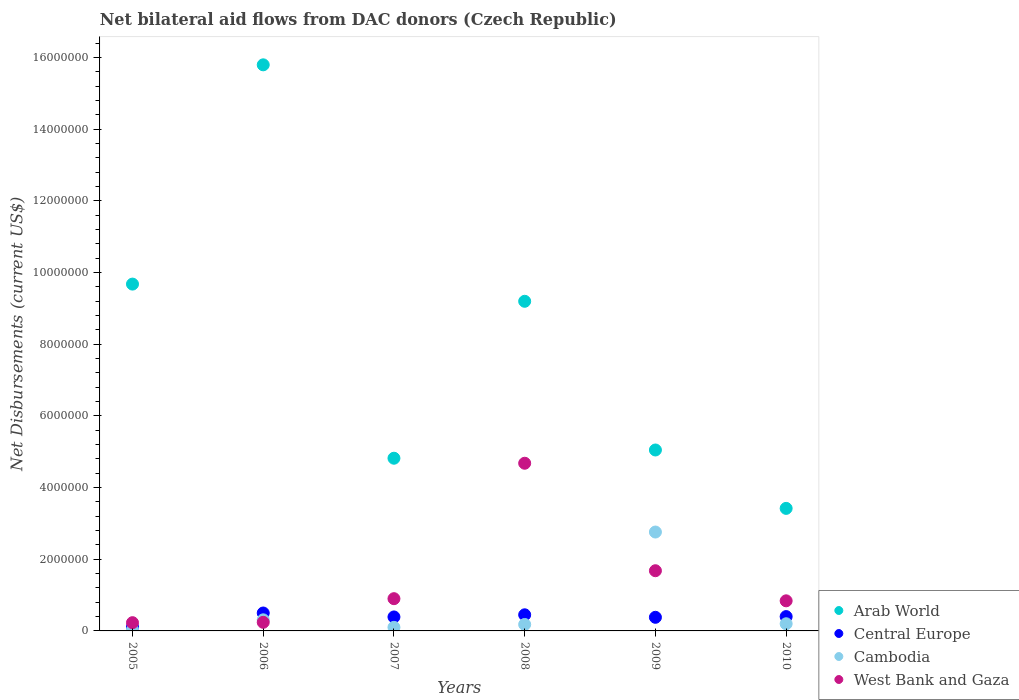How many different coloured dotlines are there?
Ensure brevity in your answer.  4. What is the net bilateral aid flows in West Bank and Gaza in 2010?
Ensure brevity in your answer.  8.40e+05. Across all years, what is the maximum net bilateral aid flows in Central Europe?
Your response must be concise. 5.00e+05. Across all years, what is the minimum net bilateral aid flows in Cambodia?
Your answer should be very brief. 3.00e+04. In which year was the net bilateral aid flows in Arab World maximum?
Your response must be concise. 2006. What is the total net bilateral aid flows in Central Europe in the graph?
Offer a very short reply. 2.23e+06. What is the difference between the net bilateral aid flows in Central Europe in 2006 and the net bilateral aid flows in Cambodia in 2010?
Make the answer very short. 3.00e+05. What is the average net bilateral aid flows in Cambodia per year?
Your response must be concise. 5.97e+05. In the year 2006, what is the difference between the net bilateral aid flows in Arab World and net bilateral aid flows in West Bank and Gaza?
Give a very brief answer. 1.56e+07. In how many years, is the net bilateral aid flows in Arab World greater than 9600000 US$?
Give a very brief answer. 2. What is the ratio of the net bilateral aid flows in Cambodia in 2006 to that in 2007?
Ensure brevity in your answer.  3.1. Is the difference between the net bilateral aid flows in Arab World in 2007 and 2008 greater than the difference between the net bilateral aid flows in West Bank and Gaza in 2007 and 2008?
Make the answer very short. No. What is the difference between the highest and the second highest net bilateral aid flows in Arab World?
Offer a terse response. 6.12e+06. What is the difference between the highest and the lowest net bilateral aid flows in Arab World?
Give a very brief answer. 1.24e+07. Does the net bilateral aid flows in Arab World monotonically increase over the years?
Provide a succinct answer. No. Is the net bilateral aid flows in West Bank and Gaza strictly greater than the net bilateral aid flows in Cambodia over the years?
Provide a short and direct response. No. Is the net bilateral aid flows in Central Europe strictly less than the net bilateral aid flows in Cambodia over the years?
Your answer should be very brief. No. Are the values on the major ticks of Y-axis written in scientific E-notation?
Make the answer very short. No. Does the graph contain any zero values?
Your response must be concise. No. How many legend labels are there?
Your answer should be very brief. 4. How are the legend labels stacked?
Your response must be concise. Vertical. What is the title of the graph?
Your response must be concise. Net bilateral aid flows from DAC donors (Czech Republic). Does "Turks and Caicos Islands" appear as one of the legend labels in the graph?
Your answer should be compact. No. What is the label or title of the X-axis?
Your response must be concise. Years. What is the label or title of the Y-axis?
Offer a terse response. Net Disbursements (current US$). What is the Net Disbursements (current US$) of Arab World in 2005?
Make the answer very short. 9.68e+06. What is the Net Disbursements (current US$) in West Bank and Gaza in 2005?
Keep it short and to the point. 2.30e+05. What is the Net Disbursements (current US$) in Arab World in 2006?
Give a very brief answer. 1.58e+07. What is the Net Disbursements (current US$) in Central Europe in 2006?
Your answer should be very brief. 5.00e+05. What is the Net Disbursements (current US$) of Arab World in 2007?
Your response must be concise. 4.82e+06. What is the Net Disbursements (current US$) of Central Europe in 2007?
Offer a terse response. 3.90e+05. What is the Net Disbursements (current US$) of Cambodia in 2007?
Your answer should be very brief. 1.00e+05. What is the Net Disbursements (current US$) in Arab World in 2008?
Offer a terse response. 9.20e+06. What is the Net Disbursements (current US$) in Central Europe in 2008?
Provide a succinct answer. 4.50e+05. What is the Net Disbursements (current US$) of West Bank and Gaza in 2008?
Offer a very short reply. 4.68e+06. What is the Net Disbursements (current US$) in Arab World in 2009?
Offer a terse response. 5.05e+06. What is the Net Disbursements (current US$) in Cambodia in 2009?
Make the answer very short. 2.76e+06. What is the Net Disbursements (current US$) in West Bank and Gaza in 2009?
Offer a very short reply. 1.68e+06. What is the Net Disbursements (current US$) of Arab World in 2010?
Make the answer very short. 3.42e+06. What is the Net Disbursements (current US$) of Cambodia in 2010?
Your answer should be very brief. 2.00e+05. What is the Net Disbursements (current US$) of West Bank and Gaza in 2010?
Your answer should be very brief. 8.40e+05. Across all years, what is the maximum Net Disbursements (current US$) in Arab World?
Your response must be concise. 1.58e+07. Across all years, what is the maximum Net Disbursements (current US$) of Cambodia?
Provide a short and direct response. 2.76e+06. Across all years, what is the maximum Net Disbursements (current US$) of West Bank and Gaza?
Your answer should be compact. 4.68e+06. Across all years, what is the minimum Net Disbursements (current US$) of Arab World?
Offer a very short reply. 3.42e+06. Across all years, what is the minimum Net Disbursements (current US$) in Central Europe?
Offer a very short reply. 1.10e+05. What is the total Net Disbursements (current US$) of Arab World in the graph?
Make the answer very short. 4.80e+07. What is the total Net Disbursements (current US$) of Central Europe in the graph?
Provide a succinct answer. 2.23e+06. What is the total Net Disbursements (current US$) of Cambodia in the graph?
Your answer should be very brief. 3.58e+06. What is the total Net Disbursements (current US$) in West Bank and Gaza in the graph?
Offer a terse response. 8.57e+06. What is the difference between the Net Disbursements (current US$) in Arab World in 2005 and that in 2006?
Offer a terse response. -6.12e+06. What is the difference between the Net Disbursements (current US$) of Central Europe in 2005 and that in 2006?
Your answer should be very brief. -3.90e+05. What is the difference between the Net Disbursements (current US$) of Cambodia in 2005 and that in 2006?
Give a very brief answer. -2.80e+05. What is the difference between the Net Disbursements (current US$) in Arab World in 2005 and that in 2007?
Give a very brief answer. 4.86e+06. What is the difference between the Net Disbursements (current US$) in Central Europe in 2005 and that in 2007?
Make the answer very short. -2.80e+05. What is the difference between the Net Disbursements (current US$) in Cambodia in 2005 and that in 2007?
Offer a terse response. -7.00e+04. What is the difference between the Net Disbursements (current US$) of West Bank and Gaza in 2005 and that in 2007?
Your response must be concise. -6.70e+05. What is the difference between the Net Disbursements (current US$) in Central Europe in 2005 and that in 2008?
Your answer should be compact. -3.40e+05. What is the difference between the Net Disbursements (current US$) of West Bank and Gaza in 2005 and that in 2008?
Offer a very short reply. -4.45e+06. What is the difference between the Net Disbursements (current US$) in Arab World in 2005 and that in 2009?
Offer a terse response. 4.63e+06. What is the difference between the Net Disbursements (current US$) in Central Europe in 2005 and that in 2009?
Offer a terse response. -2.70e+05. What is the difference between the Net Disbursements (current US$) in Cambodia in 2005 and that in 2009?
Your answer should be compact. -2.73e+06. What is the difference between the Net Disbursements (current US$) in West Bank and Gaza in 2005 and that in 2009?
Your answer should be compact. -1.45e+06. What is the difference between the Net Disbursements (current US$) of Arab World in 2005 and that in 2010?
Give a very brief answer. 6.26e+06. What is the difference between the Net Disbursements (current US$) in Central Europe in 2005 and that in 2010?
Your response must be concise. -2.90e+05. What is the difference between the Net Disbursements (current US$) in Cambodia in 2005 and that in 2010?
Ensure brevity in your answer.  -1.70e+05. What is the difference between the Net Disbursements (current US$) in West Bank and Gaza in 2005 and that in 2010?
Your answer should be compact. -6.10e+05. What is the difference between the Net Disbursements (current US$) in Arab World in 2006 and that in 2007?
Provide a short and direct response. 1.10e+07. What is the difference between the Net Disbursements (current US$) of Central Europe in 2006 and that in 2007?
Your answer should be very brief. 1.10e+05. What is the difference between the Net Disbursements (current US$) of Cambodia in 2006 and that in 2007?
Ensure brevity in your answer.  2.10e+05. What is the difference between the Net Disbursements (current US$) in West Bank and Gaza in 2006 and that in 2007?
Keep it short and to the point. -6.60e+05. What is the difference between the Net Disbursements (current US$) in Arab World in 2006 and that in 2008?
Your response must be concise. 6.60e+06. What is the difference between the Net Disbursements (current US$) in Central Europe in 2006 and that in 2008?
Keep it short and to the point. 5.00e+04. What is the difference between the Net Disbursements (current US$) of Cambodia in 2006 and that in 2008?
Make the answer very short. 1.30e+05. What is the difference between the Net Disbursements (current US$) of West Bank and Gaza in 2006 and that in 2008?
Give a very brief answer. -4.44e+06. What is the difference between the Net Disbursements (current US$) of Arab World in 2006 and that in 2009?
Keep it short and to the point. 1.08e+07. What is the difference between the Net Disbursements (current US$) of Cambodia in 2006 and that in 2009?
Provide a succinct answer. -2.45e+06. What is the difference between the Net Disbursements (current US$) of West Bank and Gaza in 2006 and that in 2009?
Give a very brief answer. -1.44e+06. What is the difference between the Net Disbursements (current US$) in Arab World in 2006 and that in 2010?
Your answer should be very brief. 1.24e+07. What is the difference between the Net Disbursements (current US$) in Central Europe in 2006 and that in 2010?
Keep it short and to the point. 1.00e+05. What is the difference between the Net Disbursements (current US$) of West Bank and Gaza in 2006 and that in 2010?
Provide a succinct answer. -6.00e+05. What is the difference between the Net Disbursements (current US$) in Arab World in 2007 and that in 2008?
Provide a succinct answer. -4.38e+06. What is the difference between the Net Disbursements (current US$) in Central Europe in 2007 and that in 2008?
Provide a short and direct response. -6.00e+04. What is the difference between the Net Disbursements (current US$) of Cambodia in 2007 and that in 2008?
Offer a very short reply. -8.00e+04. What is the difference between the Net Disbursements (current US$) of West Bank and Gaza in 2007 and that in 2008?
Make the answer very short. -3.78e+06. What is the difference between the Net Disbursements (current US$) in Cambodia in 2007 and that in 2009?
Your answer should be compact. -2.66e+06. What is the difference between the Net Disbursements (current US$) of West Bank and Gaza in 2007 and that in 2009?
Offer a terse response. -7.80e+05. What is the difference between the Net Disbursements (current US$) in Arab World in 2007 and that in 2010?
Ensure brevity in your answer.  1.40e+06. What is the difference between the Net Disbursements (current US$) in Central Europe in 2007 and that in 2010?
Keep it short and to the point. -10000. What is the difference between the Net Disbursements (current US$) in Arab World in 2008 and that in 2009?
Your response must be concise. 4.15e+06. What is the difference between the Net Disbursements (current US$) of Cambodia in 2008 and that in 2009?
Offer a terse response. -2.58e+06. What is the difference between the Net Disbursements (current US$) of Arab World in 2008 and that in 2010?
Make the answer very short. 5.78e+06. What is the difference between the Net Disbursements (current US$) in Central Europe in 2008 and that in 2010?
Offer a very short reply. 5.00e+04. What is the difference between the Net Disbursements (current US$) in West Bank and Gaza in 2008 and that in 2010?
Give a very brief answer. 3.84e+06. What is the difference between the Net Disbursements (current US$) in Arab World in 2009 and that in 2010?
Offer a terse response. 1.63e+06. What is the difference between the Net Disbursements (current US$) in Cambodia in 2009 and that in 2010?
Your response must be concise. 2.56e+06. What is the difference between the Net Disbursements (current US$) of West Bank and Gaza in 2009 and that in 2010?
Your answer should be very brief. 8.40e+05. What is the difference between the Net Disbursements (current US$) in Arab World in 2005 and the Net Disbursements (current US$) in Central Europe in 2006?
Ensure brevity in your answer.  9.18e+06. What is the difference between the Net Disbursements (current US$) in Arab World in 2005 and the Net Disbursements (current US$) in Cambodia in 2006?
Provide a succinct answer. 9.37e+06. What is the difference between the Net Disbursements (current US$) of Arab World in 2005 and the Net Disbursements (current US$) of West Bank and Gaza in 2006?
Offer a very short reply. 9.44e+06. What is the difference between the Net Disbursements (current US$) in Central Europe in 2005 and the Net Disbursements (current US$) in Cambodia in 2006?
Ensure brevity in your answer.  -2.00e+05. What is the difference between the Net Disbursements (current US$) of Central Europe in 2005 and the Net Disbursements (current US$) of West Bank and Gaza in 2006?
Your answer should be compact. -1.30e+05. What is the difference between the Net Disbursements (current US$) in Cambodia in 2005 and the Net Disbursements (current US$) in West Bank and Gaza in 2006?
Make the answer very short. -2.10e+05. What is the difference between the Net Disbursements (current US$) in Arab World in 2005 and the Net Disbursements (current US$) in Central Europe in 2007?
Offer a terse response. 9.29e+06. What is the difference between the Net Disbursements (current US$) in Arab World in 2005 and the Net Disbursements (current US$) in Cambodia in 2007?
Make the answer very short. 9.58e+06. What is the difference between the Net Disbursements (current US$) of Arab World in 2005 and the Net Disbursements (current US$) of West Bank and Gaza in 2007?
Make the answer very short. 8.78e+06. What is the difference between the Net Disbursements (current US$) of Central Europe in 2005 and the Net Disbursements (current US$) of Cambodia in 2007?
Your answer should be compact. 10000. What is the difference between the Net Disbursements (current US$) in Central Europe in 2005 and the Net Disbursements (current US$) in West Bank and Gaza in 2007?
Keep it short and to the point. -7.90e+05. What is the difference between the Net Disbursements (current US$) of Cambodia in 2005 and the Net Disbursements (current US$) of West Bank and Gaza in 2007?
Keep it short and to the point. -8.70e+05. What is the difference between the Net Disbursements (current US$) of Arab World in 2005 and the Net Disbursements (current US$) of Central Europe in 2008?
Provide a succinct answer. 9.23e+06. What is the difference between the Net Disbursements (current US$) of Arab World in 2005 and the Net Disbursements (current US$) of Cambodia in 2008?
Ensure brevity in your answer.  9.50e+06. What is the difference between the Net Disbursements (current US$) in Arab World in 2005 and the Net Disbursements (current US$) in West Bank and Gaza in 2008?
Provide a succinct answer. 5.00e+06. What is the difference between the Net Disbursements (current US$) of Central Europe in 2005 and the Net Disbursements (current US$) of Cambodia in 2008?
Keep it short and to the point. -7.00e+04. What is the difference between the Net Disbursements (current US$) of Central Europe in 2005 and the Net Disbursements (current US$) of West Bank and Gaza in 2008?
Your answer should be very brief. -4.57e+06. What is the difference between the Net Disbursements (current US$) in Cambodia in 2005 and the Net Disbursements (current US$) in West Bank and Gaza in 2008?
Ensure brevity in your answer.  -4.65e+06. What is the difference between the Net Disbursements (current US$) of Arab World in 2005 and the Net Disbursements (current US$) of Central Europe in 2009?
Make the answer very short. 9.30e+06. What is the difference between the Net Disbursements (current US$) in Arab World in 2005 and the Net Disbursements (current US$) in Cambodia in 2009?
Ensure brevity in your answer.  6.92e+06. What is the difference between the Net Disbursements (current US$) in Arab World in 2005 and the Net Disbursements (current US$) in West Bank and Gaza in 2009?
Provide a short and direct response. 8.00e+06. What is the difference between the Net Disbursements (current US$) in Central Europe in 2005 and the Net Disbursements (current US$) in Cambodia in 2009?
Your answer should be very brief. -2.65e+06. What is the difference between the Net Disbursements (current US$) of Central Europe in 2005 and the Net Disbursements (current US$) of West Bank and Gaza in 2009?
Offer a very short reply. -1.57e+06. What is the difference between the Net Disbursements (current US$) of Cambodia in 2005 and the Net Disbursements (current US$) of West Bank and Gaza in 2009?
Make the answer very short. -1.65e+06. What is the difference between the Net Disbursements (current US$) of Arab World in 2005 and the Net Disbursements (current US$) of Central Europe in 2010?
Your answer should be compact. 9.28e+06. What is the difference between the Net Disbursements (current US$) of Arab World in 2005 and the Net Disbursements (current US$) of Cambodia in 2010?
Your response must be concise. 9.48e+06. What is the difference between the Net Disbursements (current US$) in Arab World in 2005 and the Net Disbursements (current US$) in West Bank and Gaza in 2010?
Make the answer very short. 8.84e+06. What is the difference between the Net Disbursements (current US$) in Central Europe in 2005 and the Net Disbursements (current US$) in West Bank and Gaza in 2010?
Your response must be concise. -7.30e+05. What is the difference between the Net Disbursements (current US$) in Cambodia in 2005 and the Net Disbursements (current US$) in West Bank and Gaza in 2010?
Give a very brief answer. -8.10e+05. What is the difference between the Net Disbursements (current US$) in Arab World in 2006 and the Net Disbursements (current US$) in Central Europe in 2007?
Ensure brevity in your answer.  1.54e+07. What is the difference between the Net Disbursements (current US$) in Arab World in 2006 and the Net Disbursements (current US$) in Cambodia in 2007?
Your answer should be very brief. 1.57e+07. What is the difference between the Net Disbursements (current US$) of Arab World in 2006 and the Net Disbursements (current US$) of West Bank and Gaza in 2007?
Keep it short and to the point. 1.49e+07. What is the difference between the Net Disbursements (current US$) of Central Europe in 2006 and the Net Disbursements (current US$) of West Bank and Gaza in 2007?
Your answer should be compact. -4.00e+05. What is the difference between the Net Disbursements (current US$) of Cambodia in 2006 and the Net Disbursements (current US$) of West Bank and Gaza in 2007?
Make the answer very short. -5.90e+05. What is the difference between the Net Disbursements (current US$) of Arab World in 2006 and the Net Disbursements (current US$) of Central Europe in 2008?
Keep it short and to the point. 1.54e+07. What is the difference between the Net Disbursements (current US$) in Arab World in 2006 and the Net Disbursements (current US$) in Cambodia in 2008?
Your answer should be compact. 1.56e+07. What is the difference between the Net Disbursements (current US$) of Arab World in 2006 and the Net Disbursements (current US$) of West Bank and Gaza in 2008?
Make the answer very short. 1.11e+07. What is the difference between the Net Disbursements (current US$) in Central Europe in 2006 and the Net Disbursements (current US$) in Cambodia in 2008?
Your answer should be compact. 3.20e+05. What is the difference between the Net Disbursements (current US$) in Central Europe in 2006 and the Net Disbursements (current US$) in West Bank and Gaza in 2008?
Your answer should be compact. -4.18e+06. What is the difference between the Net Disbursements (current US$) of Cambodia in 2006 and the Net Disbursements (current US$) of West Bank and Gaza in 2008?
Keep it short and to the point. -4.37e+06. What is the difference between the Net Disbursements (current US$) in Arab World in 2006 and the Net Disbursements (current US$) in Central Europe in 2009?
Your answer should be compact. 1.54e+07. What is the difference between the Net Disbursements (current US$) of Arab World in 2006 and the Net Disbursements (current US$) of Cambodia in 2009?
Your answer should be compact. 1.30e+07. What is the difference between the Net Disbursements (current US$) in Arab World in 2006 and the Net Disbursements (current US$) in West Bank and Gaza in 2009?
Offer a very short reply. 1.41e+07. What is the difference between the Net Disbursements (current US$) of Central Europe in 2006 and the Net Disbursements (current US$) of Cambodia in 2009?
Offer a terse response. -2.26e+06. What is the difference between the Net Disbursements (current US$) in Central Europe in 2006 and the Net Disbursements (current US$) in West Bank and Gaza in 2009?
Provide a succinct answer. -1.18e+06. What is the difference between the Net Disbursements (current US$) in Cambodia in 2006 and the Net Disbursements (current US$) in West Bank and Gaza in 2009?
Offer a terse response. -1.37e+06. What is the difference between the Net Disbursements (current US$) of Arab World in 2006 and the Net Disbursements (current US$) of Central Europe in 2010?
Offer a terse response. 1.54e+07. What is the difference between the Net Disbursements (current US$) of Arab World in 2006 and the Net Disbursements (current US$) of Cambodia in 2010?
Give a very brief answer. 1.56e+07. What is the difference between the Net Disbursements (current US$) in Arab World in 2006 and the Net Disbursements (current US$) in West Bank and Gaza in 2010?
Keep it short and to the point. 1.50e+07. What is the difference between the Net Disbursements (current US$) of Central Europe in 2006 and the Net Disbursements (current US$) of West Bank and Gaza in 2010?
Give a very brief answer. -3.40e+05. What is the difference between the Net Disbursements (current US$) of Cambodia in 2006 and the Net Disbursements (current US$) of West Bank and Gaza in 2010?
Offer a terse response. -5.30e+05. What is the difference between the Net Disbursements (current US$) in Arab World in 2007 and the Net Disbursements (current US$) in Central Europe in 2008?
Your answer should be compact. 4.37e+06. What is the difference between the Net Disbursements (current US$) in Arab World in 2007 and the Net Disbursements (current US$) in Cambodia in 2008?
Keep it short and to the point. 4.64e+06. What is the difference between the Net Disbursements (current US$) in Arab World in 2007 and the Net Disbursements (current US$) in West Bank and Gaza in 2008?
Offer a very short reply. 1.40e+05. What is the difference between the Net Disbursements (current US$) in Central Europe in 2007 and the Net Disbursements (current US$) in West Bank and Gaza in 2008?
Your answer should be very brief. -4.29e+06. What is the difference between the Net Disbursements (current US$) of Cambodia in 2007 and the Net Disbursements (current US$) of West Bank and Gaza in 2008?
Your answer should be compact. -4.58e+06. What is the difference between the Net Disbursements (current US$) in Arab World in 2007 and the Net Disbursements (current US$) in Central Europe in 2009?
Offer a very short reply. 4.44e+06. What is the difference between the Net Disbursements (current US$) in Arab World in 2007 and the Net Disbursements (current US$) in Cambodia in 2009?
Provide a short and direct response. 2.06e+06. What is the difference between the Net Disbursements (current US$) in Arab World in 2007 and the Net Disbursements (current US$) in West Bank and Gaza in 2009?
Keep it short and to the point. 3.14e+06. What is the difference between the Net Disbursements (current US$) in Central Europe in 2007 and the Net Disbursements (current US$) in Cambodia in 2009?
Your answer should be compact. -2.37e+06. What is the difference between the Net Disbursements (current US$) in Central Europe in 2007 and the Net Disbursements (current US$) in West Bank and Gaza in 2009?
Offer a terse response. -1.29e+06. What is the difference between the Net Disbursements (current US$) in Cambodia in 2007 and the Net Disbursements (current US$) in West Bank and Gaza in 2009?
Provide a succinct answer. -1.58e+06. What is the difference between the Net Disbursements (current US$) in Arab World in 2007 and the Net Disbursements (current US$) in Central Europe in 2010?
Your answer should be compact. 4.42e+06. What is the difference between the Net Disbursements (current US$) of Arab World in 2007 and the Net Disbursements (current US$) of Cambodia in 2010?
Offer a very short reply. 4.62e+06. What is the difference between the Net Disbursements (current US$) of Arab World in 2007 and the Net Disbursements (current US$) of West Bank and Gaza in 2010?
Provide a short and direct response. 3.98e+06. What is the difference between the Net Disbursements (current US$) in Central Europe in 2007 and the Net Disbursements (current US$) in Cambodia in 2010?
Offer a terse response. 1.90e+05. What is the difference between the Net Disbursements (current US$) of Central Europe in 2007 and the Net Disbursements (current US$) of West Bank and Gaza in 2010?
Give a very brief answer. -4.50e+05. What is the difference between the Net Disbursements (current US$) of Cambodia in 2007 and the Net Disbursements (current US$) of West Bank and Gaza in 2010?
Give a very brief answer. -7.40e+05. What is the difference between the Net Disbursements (current US$) of Arab World in 2008 and the Net Disbursements (current US$) of Central Europe in 2009?
Provide a short and direct response. 8.82e+06. What is the difference between the Net Disbursements (current US$) of Arab World in 2008 and the Net Disbursements (current US$) of Cambodia in 2009?
Keep it short and to the point. 6.44e+06. What is the difference between the Net Disbursements (current US$) of Arab World in 2008 and the Net Disbursements (current US$) of West Bank and Gaza in 2009?
Offer a very short reply. 7.52e+06. What is the difference between the Net Disbursements (current US$) in Central Europe in 2008 and the Net Disbursements (current US$) in Cambodia in 2009?
Make the answer very short. -2.31e+06. What is the difference between the Net Disbursements (current US$) in Central Europe in 2008 and the Net Disbursements (current US$) in West Bank and Gaza in 2009?
Give a very brief answer. -1.23e+06. What is the difference between the Net Disbursements (current US$) of Cambodia in 2008 and the Net Disbursements (current US$) of West Bank and Gaza in 2009?
Ensure brevity in your answer.  -1.50e+06. What is the difference between the Net Disbursements (current US$) of Arab World in 2008 and the Net Disbursements (current US$) of Central Europe in 2010?
Provide a short and direct response. 8.80e+06. What is the difference between the Net Disbursements (current US$) of Arab World in 2008 and the Net Disbursements (current US$) of Cambodia in 2010?
Make the answer very short. 9.00e+06. What is the difference between the Net Disbursements (current US$) in Arab World in 2008 and the Net Disbursements (current US$) in West Bank and Gaza in 2010?
Offer a terse response. 8.36e+06. What is the difference between the Net Disbursements (current US$) in Central Europe in 2008 and the Net Disbursements (current US$) in West Bank and Gaza in 2010?
Provide a short and direct response. -3.90e+05. What is the difference between the Net Disbursements (current US$) in Cambodia in 2008 and the Net Disbursements (current US$) in West Bank and Gaza in 2010?
Offer a terse response. -6.60e+05. What is the difference between the Net Disbursements (current US$) of Arab World in 2009 and the Net Disbursements (current US$) of Central Europe in 2010?
Offer a very short reply. 4.65e+06. What is the difference between the Net Disbursements (current US$) in Arab World in 2009 and the Net Disbursements (current US$) in Cambodia in 2010?
Offer a very short reply. 4.85e+06. What is the difference between the Net Disbursements (current US$) of Arab World in 2009 and the Net Disbursements (current US$) of West Bank and Gaza in 2010?
Your answer should be very brief. 4.21e+06. What is the difference between the Net Disbursements (current US$) of Central Europe in 2009 and the Net Disbursements (current US$) of West Bank and Gaza in 2010?
Your response must be concise. -4.60e+05. What is the difference between the Net Disbursements (current US$) of Cambodia in 2009 and the Net Disbursements (current US$) of West Bank and Gaza in 2010?
Provide a succinct answer. 1.92e+06. What is the average Net Disbursements (current US$) in Arab World per year?
Ensure brevity in your answer.  8.00e+06. What is the average Net Disbursements (current US$) in Central Europe per year?
Your answer should be compact. 3.72e+05. What is the average Net Disbursements (current US$) of Cambodia per year?
Give a very brief answer. 5.97e+05. What is the average Net Disbursements (current US$) of West Bank and Gaza per year?
Ensure brevity in your answer.  1.43e+06. In the year 2005, what is the difference between the Net Disbursements (current US$) in Arab World and Net Disbursements (current US$) in Central Europe?
Offer a very short reply. 9.57e+06. In the year 2005, what is the difference between the Net Disbursements (current US$) in Arab World and Net Disbursements (current US$) in Cambodia?
Provide a succinct answer. 9.65e+06. In the year 2005, what is the difference between the Net Disbursements (current US$) in Arab World and Net Disbursements (current US$) in West Bank and Gaza?
Provide a succinct answer. 9.45e+06. In the year 2005, what is the difference between the Net Disbursements (current US$) in Central Europe and Net Disbursements (current US$) in West Bank and Gaza?
Keep it short and to the point. -1.20e+05. In the year 2006, what is the difference between the Net Disbursements (current US$) of Arab World and Net Disbursements (current US$) of Central Europe?
Your answer should be compact. 1.53e+07. In the year 2006, what is the difference between the Net Disbursements (current US$) in Arab World and Net Disbursements (current US$) in Cambodia?
Offer a terse response. 1.55e+07. In the year 2006, what is the difference between the Net Disbursements (current US$) of Arab World and Net Disbursements (current US$) of West Bank and Gaza?
Provide a succinct answer. 1.56e+07. In the year 2006, what is the difference between the Net Disbursements (current US$) in Central Europe and Net Disbursements (current US$) in Cambodia?
Provide a short and direct response. 1.90e+05. In the year 2006, what is the difference between the Net Disbursements (current US$) of Cambodia and Net Disbursements (current US$) of West Bank and Gaza?
Keep it short and to the point. 7.00e+04. In the year 2007, what is the difference between the Net Disbursements (current US$) in Arab World and Net Disbursements (current US$) in Central Europe?
Your answer should be very brief. 4.43e+06. In the year 2007, what is the difference between the Net Disbursements (current US$) of Arab World and Net Disbursements (current US$) of Cambodia?
Your response must be concise. 4.72e+06. In the year 2007, what is the difference between the Net Disbursements (current US$) of Arab World and Net Disbursements (current US$) of West Bank and Gaza?
Provide a succinct answer. 3.92e+06. In the year 2007, what is the difference between the Net Disbursements (current US$) of Central Europe and Net Disbursements (current US$) of West Bank and Gaza?
Your answer should be compact. -5.10e+05. In the year 2007, what is the difference between the Net Disbursements (current US$) in Cambodia and Net Disbursements (current US$) in West Bank and Gaza?
Ensure brevity in your answer.  -8.00e+05. In the year 2008, what is the difference between the Net Disbursements (current US$) of Arab World and Net Disbursements (current US$) of Central Europe?
Provide a short and direct response. 8.75e+06. In the year 2008, what is the difference between the Net Disbursements (current US$) of Arab World and Net Disbursements (current US$) of Cambodia?
Give a very brief answer. 9.02e+06. In the year 2008, what is the difference between the Net Disbursements (current US$) in Arab World and Net Disbursements (current US$) in West Bank and Gaza?
Your answer should be compact. 4.52e+06. In the year 2008, what is the difference between the Net Disbursements (current US$) of Central Europe and Net Disbursements (current US$) of West Bank and Gaza?
Offer a very short reply. -4.23e+06. In the year 2008, what is the difference between the Net Disbursements (current US$) of Cambodia and Net Disbursements (current US$) of West Bank and Gaza?
Keep it short and to the point. -4.50e+06. In the year 2009, what is the difference between the Net Disbursements (current US$) of Arab World and Net Disbursements (current US$) of Central Europe?
Your response must be concise. 4.67e+06. In the year 2009, what is the difference between the Net Disbursements (current US$) of Arab World and Net Disbursements (current US$) of Cambodia?
Your answer should be very brief. 2.29e+06. In the year 2009, what is the difference between the Net Disbursements (current US$) of Arab World and Net Disbursements (current US$) of West Bank and Gaza?
Offer a terse response. 3.37e+06. In the year 2009, what is the difference between the Net Disbursements (current US$) in Central Europe and Net Disbursements (current US$) in Cambodia?
Make the answer very short. -2.38e+06. In the year 2009, what is the difference between the Net Disbursements (current US$) in Central Europe and Net Disbursements (current US$) in West Bank and Gaza?
Provide a short and direct response. -1.30e+06. In the year 2009, what is the difference between the Net Disbursements (current US$) in Cambodia and Net Disbursements (current US$) in West Bank and Gaza?
Offer a terse response. 1.08e+06. In the year 2010, what is the difference between the Net Disbursements (current US$) of Arab World and Net Disbursements (current US$) of Central Europe?
Your answer should be compact. 3.02e+06. In the year 2010, what is the difference between the Net Disbursements (current US$) of Arab World and Net Disbursements (current US$) of Cambodia?
Your response must be concise. 3.22e+06. In the year 2010, what is the difference between the Net Disbursements (current US$) in Arab World and Net Disbursements (current US$) in West Bank and Gaza?
Your answer should be very brief. 2.58e+06. In the year 2010, what is the difference between the Net Disbursements (current US$) in Central Europe and Net Disbursements (current US$) in West Bank and Gaza?
Keep it short and to the point. -4.40e+05. In the year 2010, what is the difference between the Net Disbursements (current US$) of Cambodia and Net Disbursements (current US$) of West Bank and Gaza?
Provide a succinct answer. -6.40e+05. What is the ratio of the Net Disbursements (current US$) of Arab World in 2005 to that in 2006?
Make the answer very short. 0.61. What is the ratio of the Net Disbursements (current US$) of Central Europe in 2005 to that in 2006?
Your response must be concise. 0.22. What is the ratio of the Net Disbursements (current US$) in Cambodia in 2005 to that in 2006?
Make the answer very short. 0.1. What is the ratio of the Net Disbursements (current US$) of Arab World in 2005 to that in 2007?
Offer a terse response. 2.01. What is the ratio of the Net Disbursements (current US$) in Central Europe in 2005 to that in 2007?
Your answer should be very brief. 0.28. What is the ratio of the Net Disbursements (current US$) of West Bank and Gaza in 2005 to that in 2007?
Offer a terse response. 0.26. What is the ratio of the Net Disbursements (current US$) in Arab World in 2005 to that in 2008?
Your answer should be very brief. 1.05. What is the ratio of the Net Disbursements (current US$) in Central Europe in 2005 to that in 2008?
Give a very brief answer. 0.24. What is the ratio of the Net Disbursements (current US$) of West Bank and Gaza in 2005 to that in 2008?
Your answer should be compact. 0.05. What is the ratio of the Net Disbursements (current US$) in Arab World in 2005 to that in 2009?
Your answer should be compact. 1.92. What is the ratio of the Net Disbursements (current US$) of Central Europe in 2005 to that in 2009?
Give a very brief answer. 0.29. What is the ratio of the Net Disbursements (current US$) of Cambodia in 2005 to that in 2009?
Provide a succinct answer. 0.01. What is the ratio of the Net Disbursements (current US$) of West Bank and Gaza in 2005 to that in 2009?
Offer a terse response. 0.14. What is the ratio of the Net Disbursements (current US$) of Arab World in 2005 to that in 2010?
Offer a terse response. 2.83. What is the ratio of the Net Disbursements (current US$) of Central Europe in 2005 to that in 2010?
Provide a succinct answer. 0.28. What is the ratio of the Net Disbursements (current US$) of Cambodia in 2005 to that in 2010?
Your answer should be very brief. 0.15. What is the ratio of the Net Disbursements (current US$) in West Bank and Gaza in 2005 to that in 2010?
Provide a succinct answer. 0.27. What is the ratio of the Net Disbursements (current US$) of Arab World in 2006 to that in 2007?
Provide a short and direct response. 3.28. What is the ratio of the Net Disbursements (current US$) in Central Europe in 2006 to that in 2007?
Give a very brief answer. 1.28. What is the ratio of the Net Disbursements (current US$) of Cambodia in 2006 to that in 2007?
Offer a terse response. 3.1. What is the ratio of the Net Disbursements (current US$) of West Bank and Gaza in 2006 to that in 2007?
Ensure brevity in your answer.  0.27. What is the ratio of the Net Disbursements (current US$) in Arab World in 2006 to that in 2008?
Your answer should be very brief. 1.72. What is the ratio of the Net Disbursements (current US$) in Cambodia in 2006 to that in 2008?
Your response must be concise. 1.72. What is the ratio of the Net Disbursements (current US$) of West Bank and Gaza in 2006 to that in 2008?
Make the answer very short. 0.05. What is the ratio of the Net Disbursements (current US$) in Arab World in 2006 to that in 2009?
Offer a very short reply. 3.13. What is the ratio of the Net Disbursements (current US$) in Central Europe in 2006 to that in 2009?
Make the answer very short. 1.32. What is the ratio of the Net Disbursements (current US$) of Cambodia in 2006 to that in 2009?
Your response must be concise. 0.11. What is the ratio of the Net Disbursements (current US$) in West Bank and Gaza in 2006 to that in 2009?
Provide a short and direct response. 0.14. What is the ratio of the Net Disbursements (current US$) of Arab World in 2006 to that in 2010?
Your answer should be compact. 4.62. What is the ratio of the Net Disbursements (current US$) in Cambodia in 2006 to that in 2010?
Make the answer very short. 1.55. What is the ratio of the Net Disbursements (current US$) of West Bank and Gaza in 2006 to that in 2010?
Provide a succinct answer. 0.29. What is the ratio of the Net Disbursements (current US$) in Arab World in 2007 to that in 2008?
Make the answer very short. 0.52. What is the ratio of the Net Disbursements (current US$) in Central Europe in 2007 to that in 2008?
Provide a short and direct response. 0.87. What is the ratio of the Net Disbursements (current US$) of Cambodia in 2007 to that in 2008?
Ensure brevity in your answer.  0.56. What is the ratio of the Net Disbursements (current US$) in West Bank and Gaza in 2007 to that in 2008?
Keep it short and to the point. 0.19. What is the ratio of the Net Disbursements (current US$) of Arab World in 2007 to that in 2009?
Provide a succinct answer. 0.95. What is the ratio of the Net Disbursements (current US$) of Central Europe in 2007 to that in 2009?
Give a very brief answer. 1.03. What is the ratio of the Net Disbursements (current US$) in Cambodia in 2007 to that in 2009?
Offer a terse response. 0.04. What is the ratio of the Net Disbursements (current US$) of West Bank and Gaza in 2007 to that in 2009?
Your answer should be very brief. 0.54. What is the ratio of the Net Disbursements (current US$) of Arab World in 2007 to that in 2010?
Offer a terse response. 1.41. What is the ratio of the Net Disbursements (current US$) in Cambodia in 2007 to that in 2010?
Your answer should be very brief. 0.5. What is the ratio of the Net Disbursements (current US$) of West Bank and Gaza in 2007 to that in 2010?
Provide a short and direct response. 1.07. What is the ratio of the Net Disbursements (current US$) in Arab World in 2008 to that in 2009?
Offer a very short reply. 1.82. What is the ratio of the Net Disbursements (current US$) in Central Europe in 2008 to that in 2009?
Provide a succinct answer. 1.18. What is the ratio of the Net Disbursements (current US$) of Cambodia in 2008 to that in 2009?
Offer a terse response. 0.07. What is the ratio of the Net Disbursements (current US$) in West Bank and Gaza in 2008 to that in 2009?
Your answer should be compact. 2.79. What is the ratio of the Net Disbursements (current US$) in Arab World in 2008 to that in 2010?
Offer a terse response. 2.69. What is the ratio of the Net Disbursements (current US$) of Central Europe in 2008 to that in 2010?
Give a very brief answer. 1.12. What is the ratio of the Net Disbursements (current US$) in Cambodia in 2008 to that in 2010?
Ensure brevity in your answer.  0.9. What is the ratio of the Net Disbursements (current US$) of West Bank and Gaza in 2008 to that in 2010?
Your answer should be very brief. 5.57. What is the ratio of the Net Disbursements (current US$) of Arab World in 2009 to that in 2010?
Provide a short and direct response. 1.48. What is the ratio of the Net Disbursements (current US$) in Central Europe in 2009 to that in 2010?
Give a very brief answer. 0.95. What is the difference between the highest and the second highest Net Disbursements (current US$) in Arab World?
Your response must be concise. 6.12e+06. What is the difference between the highest and the second highest Net Disbursements (current US$) in Central Europe?
Provide a short and direct response. 5.00e+04. What is the difference between the highest and the second highest Net Disbursements (current US$) of Cambodia?
Offer a terse response. 2.45e+06. What is the difference between the highest and the second highest Net Disbursements (current US$) in West Bank and Gaza?
Offer a terse response. 3.00e+06. What is the difference between the highest and the lowest Net Disbursements (current US$) of Arab World?
Provide a succinct answer. 1.24e+07. What is the difference between the highest and the lowest Net Disbursements (current US$) in Central Europe?
Your answer should be compact. 3.90e+05. What is the difference between the highest and the lowest Net Disbursements (current US$) in Cambodia?
Your answer should be compact. 2.73e+06. What is the difference between the highest and the lowest Net Disbursements (current US$) in West Bank and Gaza?
Make the answer very short. 4.45e+06. 